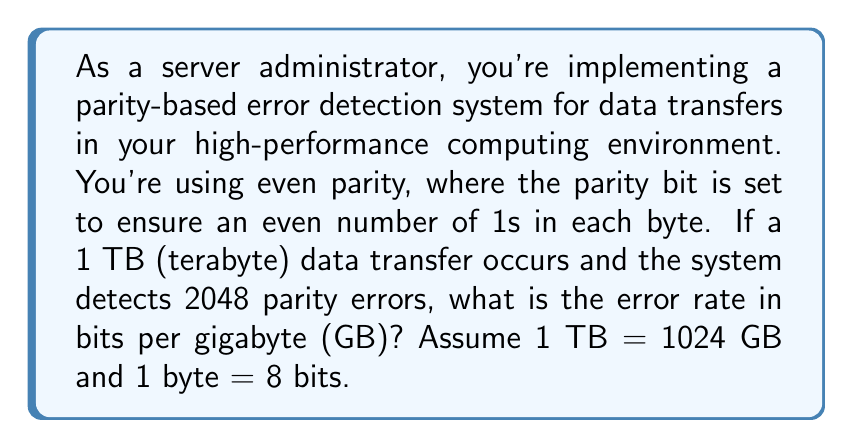Help me with this question. Let's approach this step-by-step:

1) First, we need to calculate the total number of bits transferred:
   $$ 1 \text{ TB} = 1024 \text{ GB} = 1024 \times 1024 \text{ MB} = 1024 \times 1024 \times 1024 \text{ KB} = 1024^3 \text{ KB} $$
   $$ 1024^3 \text{ KB} = 1024^4 \text{ bytes} = 1024^4 \times 8 \text{ bits} = 8,796,093,022,208 \text{ bits} $$

2) Now, we know that each parity error represents at least one bit error. However, it could be more than one bit error per byte. For a conservative estimate, we'll assume each parity error represents exactly one bit error.

3) Number of errors detected = 2048

4) To calculate the error rate in bits per GB, we need to divide the number of errors by the number of GB:
   $$ \text{Error Rate} = \frac{\text{Number of Errors}}{\text{Number of GB}} $$
   $$ \text{Error Rate} = \frac{2048 \text{ errors}}{1024 \text{ GB}} = 2 \text{ errors/GB} $$

5) Since we're asked for the rate in bits per GB, and we've assumed one error per parity error detected, this is our final answer.
Answer: 2 bits per GB 